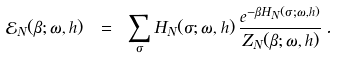Convert formula to latex. <formula><loc_0><loc_0><loc_500><loc_500>\mathcal { E } _ { N } ( \beta ; \omega , h ) \ = \ \sum _ { \sigma } H _ { N } ( \sigma ; \omega , h ) \, \frac { e ^ { - \beta H _ { N } ( \sigma ; \omega , h ) } } { Z _ { N } ( \beta ; \omega , h ) } \, .</formula> 